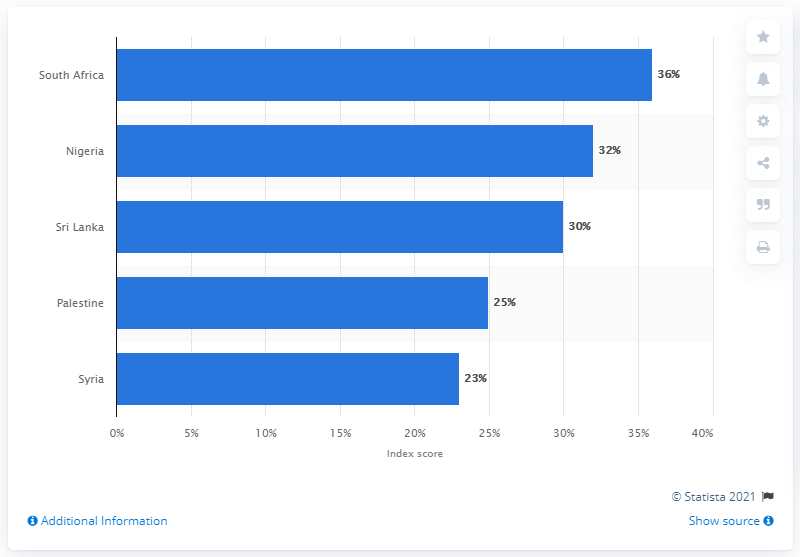Mention a couple of crucial points in this snapshot. The corporate social responsibility disclosure index score in South Africa in 2019 was 36 out of 100. 